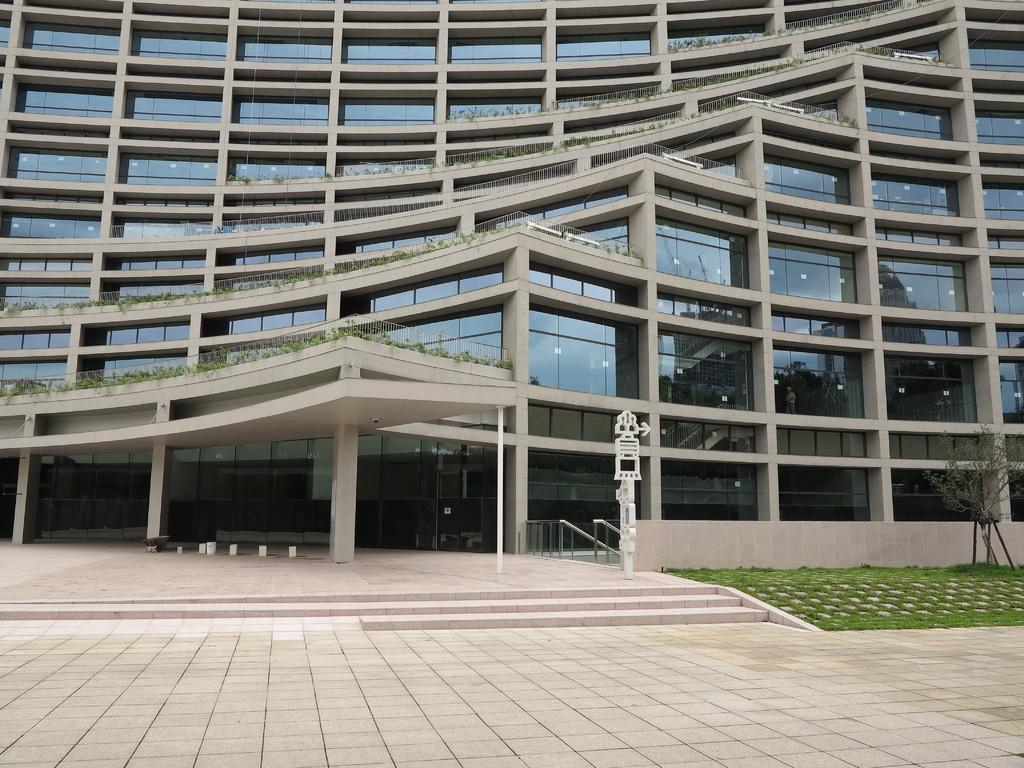Please provide a concise description of this image. In this picture I can observe a building. There are some plants on the building. I can observe some grass on the right side. 